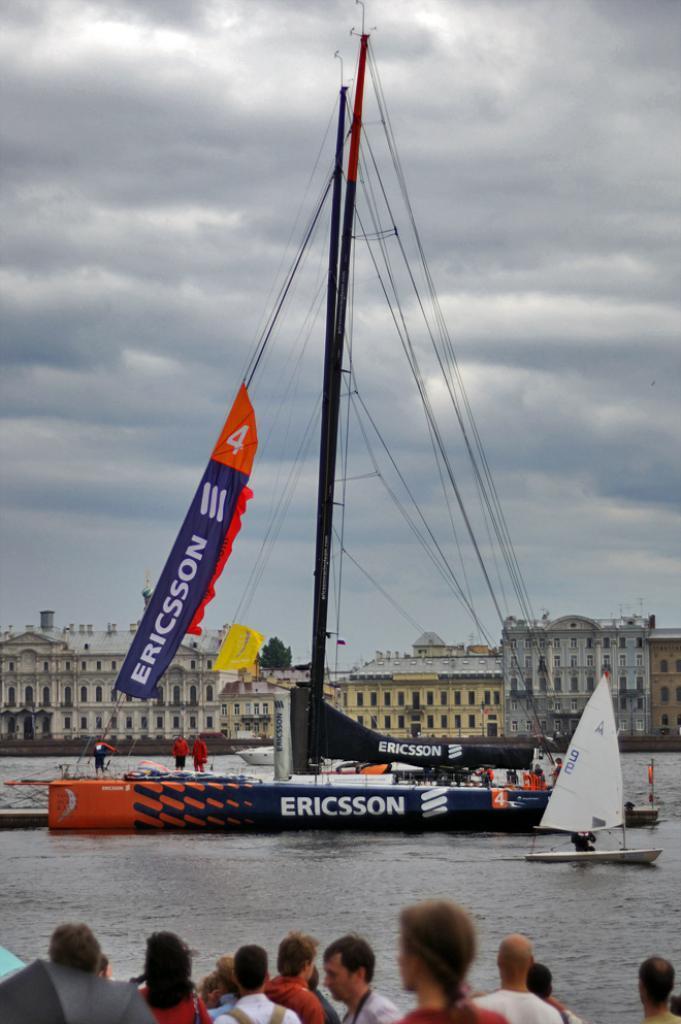How would you summarize this image in a sentence or two? In this image there is water. There is a ship. There are buildings on the backside. There are people standing near the water. 